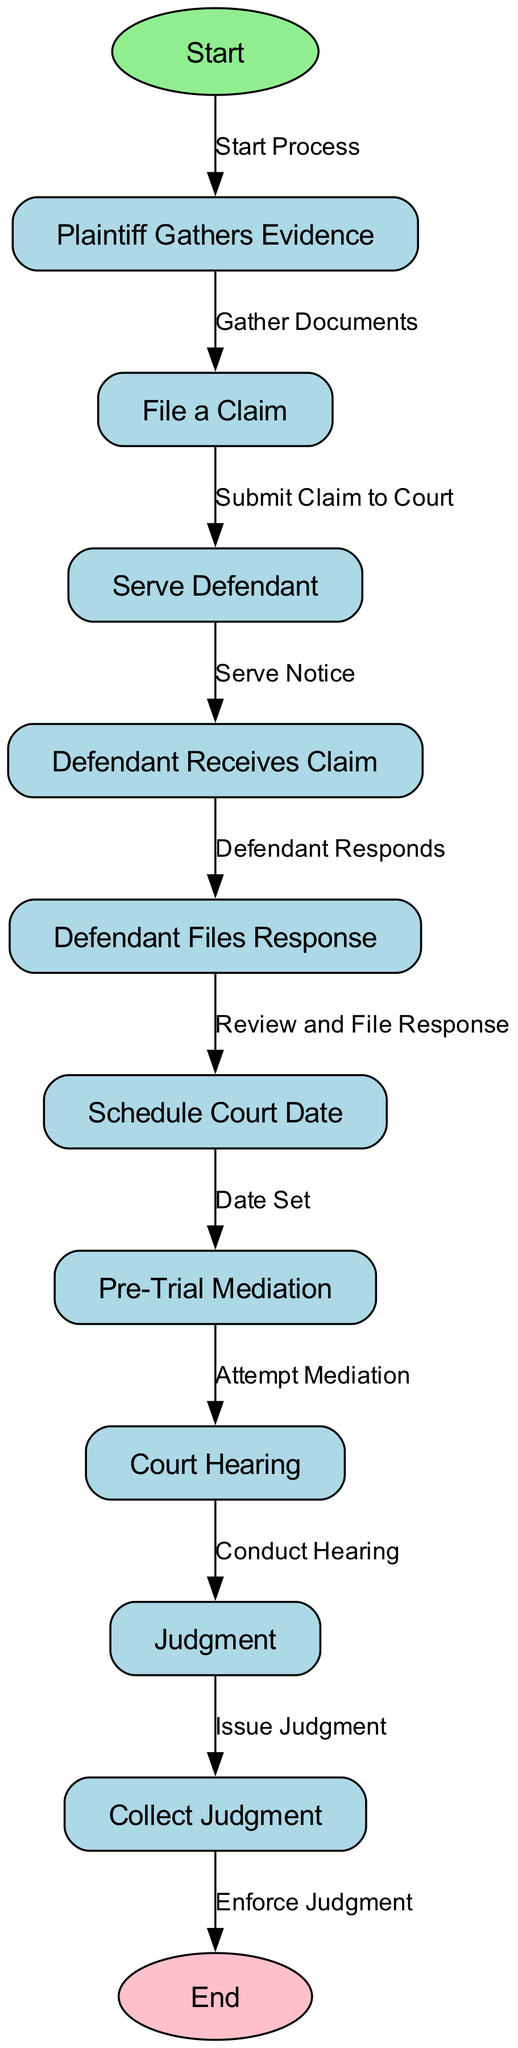What is the first step in the process? The first step in the process is represented by the node labeled "Start," which is identified as "1" in the diagram. This indicates the initiation of the small claims court process.
Answer: Start How many nodes are there in total? By counting the number of distinct elements or nodes listed in the diagram's data, there are twelve nodes present, ranging from the start to the end of the process.
Answer: Twelve What does the defendant do after receiving the claim? According to the flowchart, after receiving the claim, the defendant's next action is to file a response, which is indicated by the node labeled "Defendant Files Response." This is a direct step following the defendant receiving the claim.
Answer: Defendant Files Response What action follows after the court hearing? The action that follows the court hearing is the issuance of a judgment, as represented in the diagram. This indicates that the court hearing concludes with the court rendering a decision.
Answer: Issue Judgment What is the relationship between "Serve Defendant" and "Defendant Receives Claim"? The relationship between "Serve Defendant" and "Defendant Receives Claim" is that "Serve Defendant" is the action that leads directly to the outcome where the defendant receives the claim. This is demonstrated by the directed edge connecting these two nodes.
Answer: Serve Notice What step occurs right before the "Court Hearing"? The step that occurs right before the "Court Hearing" is "Pre-Trial Mediation," as indicated by the flow from node 8 to node 9. This suggests that mediation attempts are made before the court hearing takes place.
Answer: Pre-Trial Mediation Which node represents the conclusion of the process? The conclusion of the process is represented by the node labeled "End." This indicates that all steps have been completed and the process is finalized at this point.
Answer: End What is required from the plaintiff after gathering evidence? After gathering evidence, the plaintiff is required to file a claim, as indicated by the flow from node 2 ("Plaintiff Gathers Evidence") to node 3 ("File a Claim"). This step signifies the transition from preparation to action.
Answer: File a Claim 